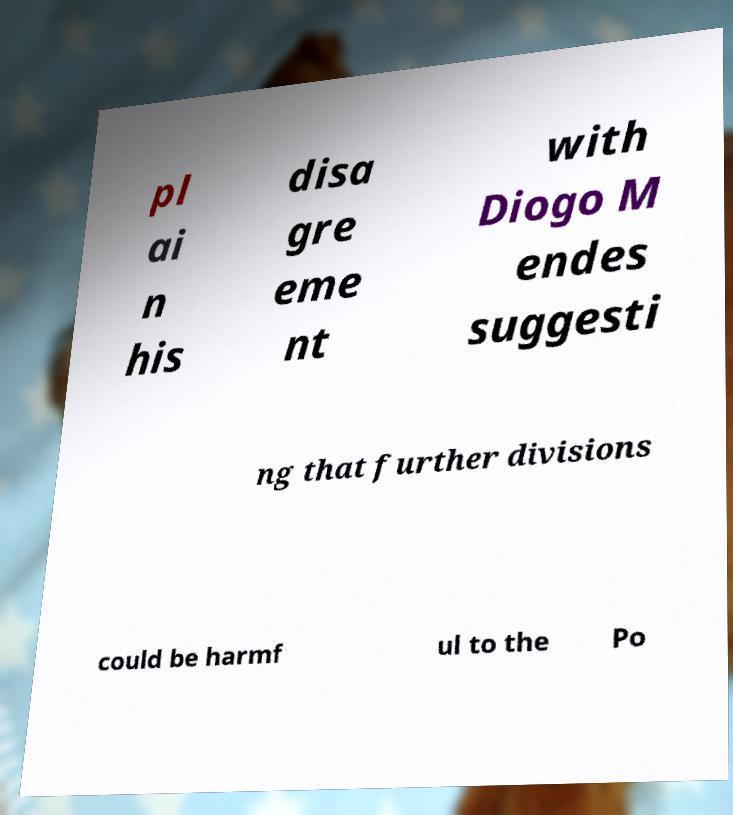I need the written content from this picture converted into text. Can you do that? pl ai n his disa gre eme nt with Diogo M endes suggesti ng that further divisions could be harmf ul to the Po 